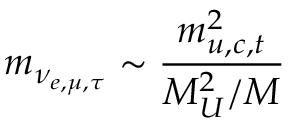<formula> <loc_0><loc_0><loc_500><loc_500>m _ { \nu _ { e , \mu , \tau } } \sim { \frac { m _ { u , c , t } ^ { 2 } } { M _ { U } ^ { 2 } / M } }</formula> 